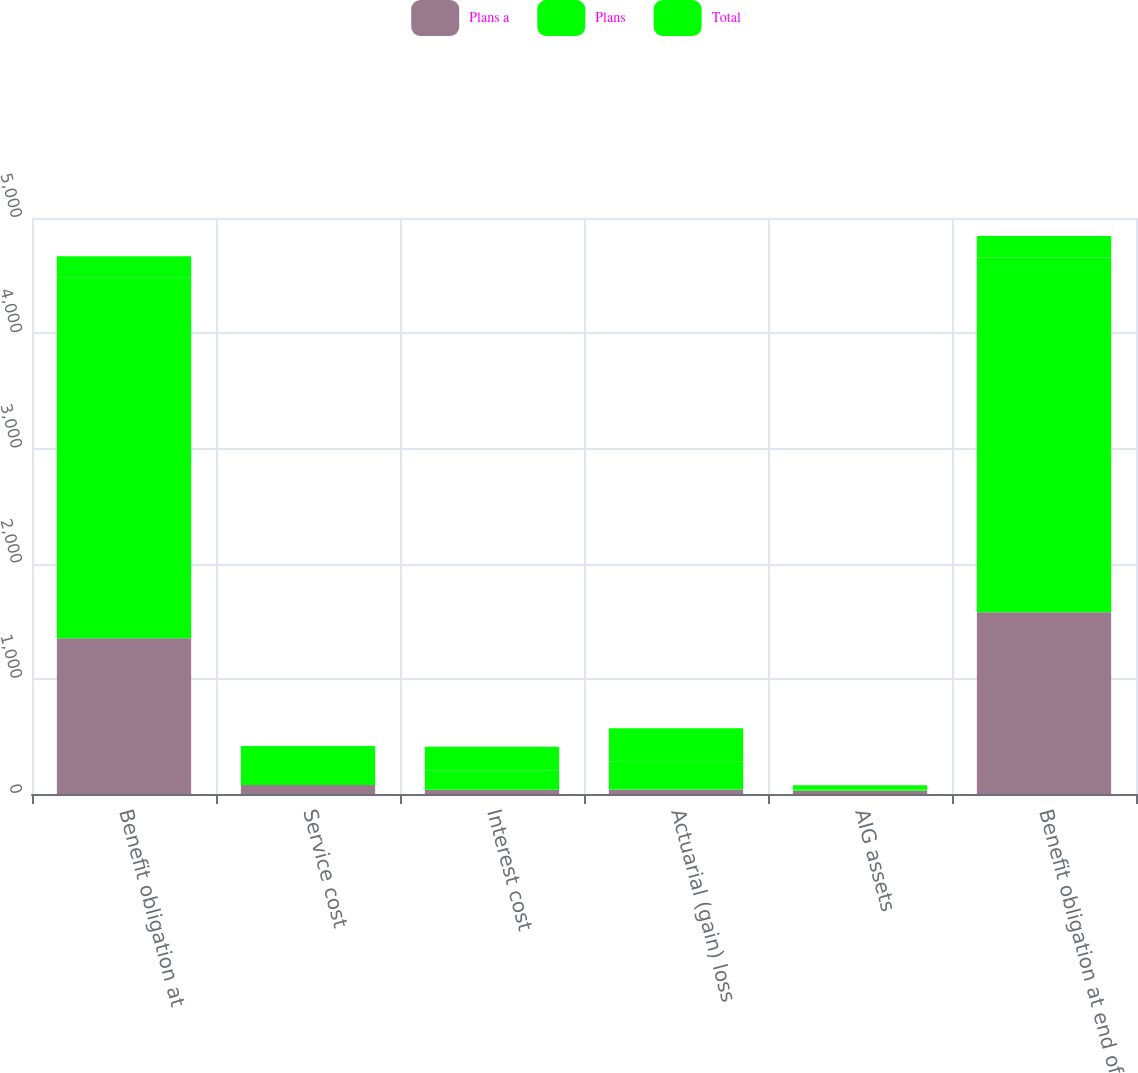<chart> <loc_0><loc_0><loc_500><loc_500><stacked_bar_chart><ecel><fcel>Benefit obligation at<fcel>Service cost<fcel>Interest cost<fcel>Actuarial (gain) loss<fcel>AIG assets<fcel>Benefit obligation at end of<nl><fcel>Plans a<fcel>1351<fcel>78<fcel>36<fcel>40<fcel>28<fcel>1578<nl><fcel>Plans<fcel>3131<fcel>130<fcel>169<fcel>245<fcel>10<fcel>3079<nl><fcel>Total<fcel>187<fcel>208<fcel>205<fcel>285<fcel>38<fcel>187<nl></chart> 